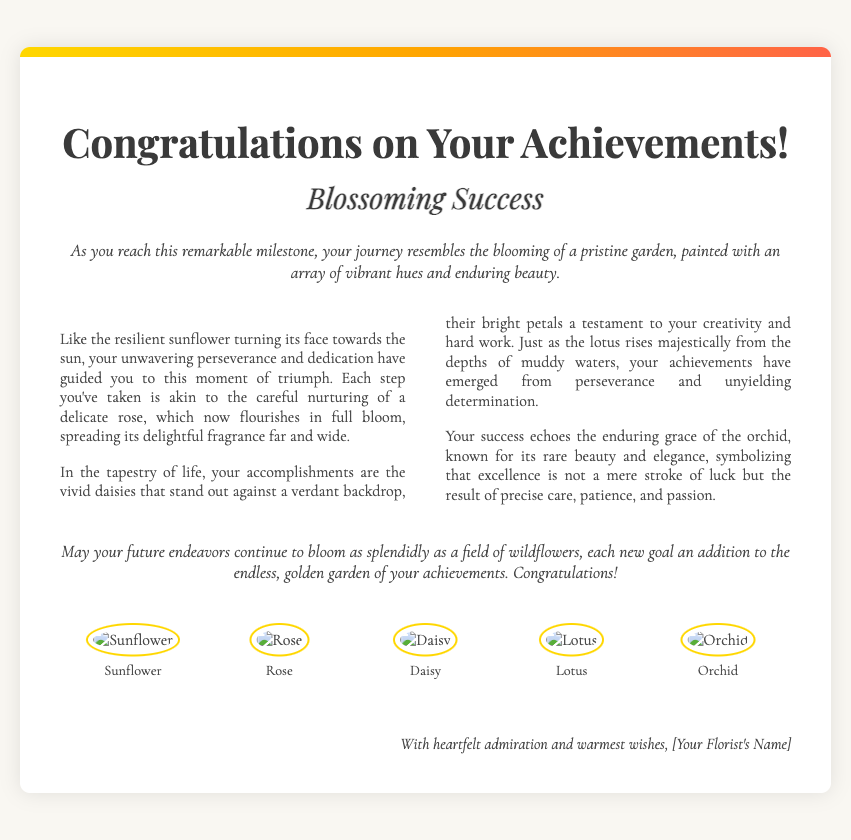What is the title of the card? The title of the card is typically prominently displayed at the top of the document.
Answer: Congratulations on Your Achievements! What are the main themes expressed in the card? The main themes are highlighted in various metaphors about success, blooming, and flowers within the text.
Answer: Success, blooming, flowers How many illustrations of flowers are included in the card? The document includes a section specifically showcasing different flower illustrations.
Answer: Five What metaphor is used to describe perseverance? The document uses a metaphor comparing perseverance to a specific flower's behavior.
Answer: Sunflower Who is the card's sender? The sender is indicated at the bottom of the card, which is typical for greeting cards.
Answer: [Your Florist's Name] What type of card is this? The structure and content suggest it fits a specific greeting card category.
Answer: Congratulatory card How is success metaphorically represented in the document? The text includes examples of positive imagery from nature to illustrate success.
Answer: Vivid daisies What color scheme is used for the card's background? The background color is part of the document's styling, described in the CSS section.
Answer: Light beige (#f9f7f2) 